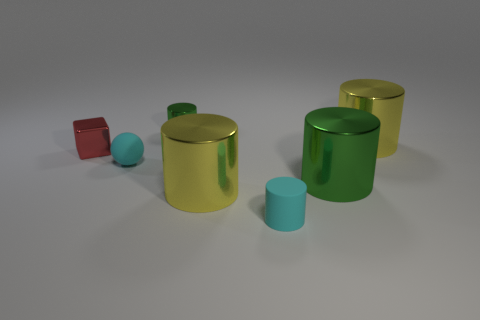Is the material of the tiny cyan cylinder the same as the tiny sphere?
Your answer should be compact. Yes. There is a cyan sphere; what number of shiny cylinders are in front of it?
Your response must be concise. 2. The other green shiny thing that is the same shape as the big green thing is what size?
Provide a short and direct response. Small. What number of green things are spheres or big cylinders?
Offer a very short reply. 1. What number of large yellow cylinders are left of the big yellow metal cylinder that is right of the small rubber cylinder?
Offer a very short reply. 1. What number of other objects are there of the same shape as the small green metallic object?
Offer a very short reply. 4. What material is the tiny object that is the same color as the sphere?
Make the answer very short. Rubber. How many large cylinders have the same color as the cube?
Provide a succinct answer. 0. There is another tiny thing that is made of the same material as the tiny red object; what is its color?
Give a very brief answer. Green. Are there any spheres of the same size as the cyan matte cylinder?
Your response must be concise. Yes. 